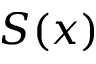<formula> <loc_0><loc_0><loc_500><loc_500>S ( x )</formula> 